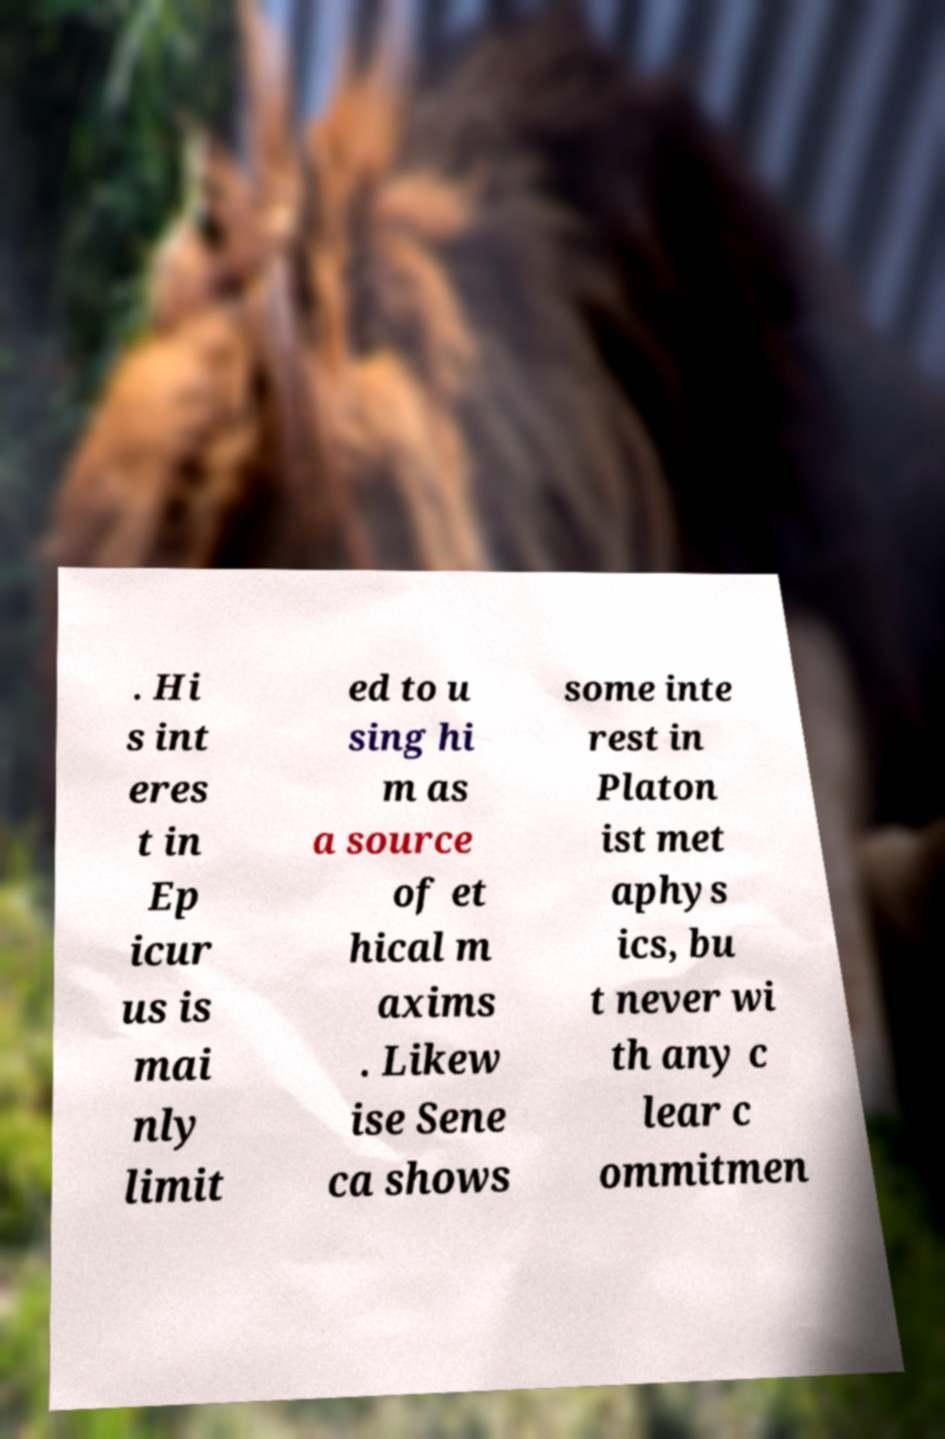What messages or text are displayed in this image? I need them in a readable, typed format. . Hi s int eres t in Ep icur us is mai nly limit ed to u sing hi m as a source of et hical m axims . Likew ise Sene ca shows some inte rest in Platon ist met aphys ics, bu t never wi th any c lear c ommitmen 